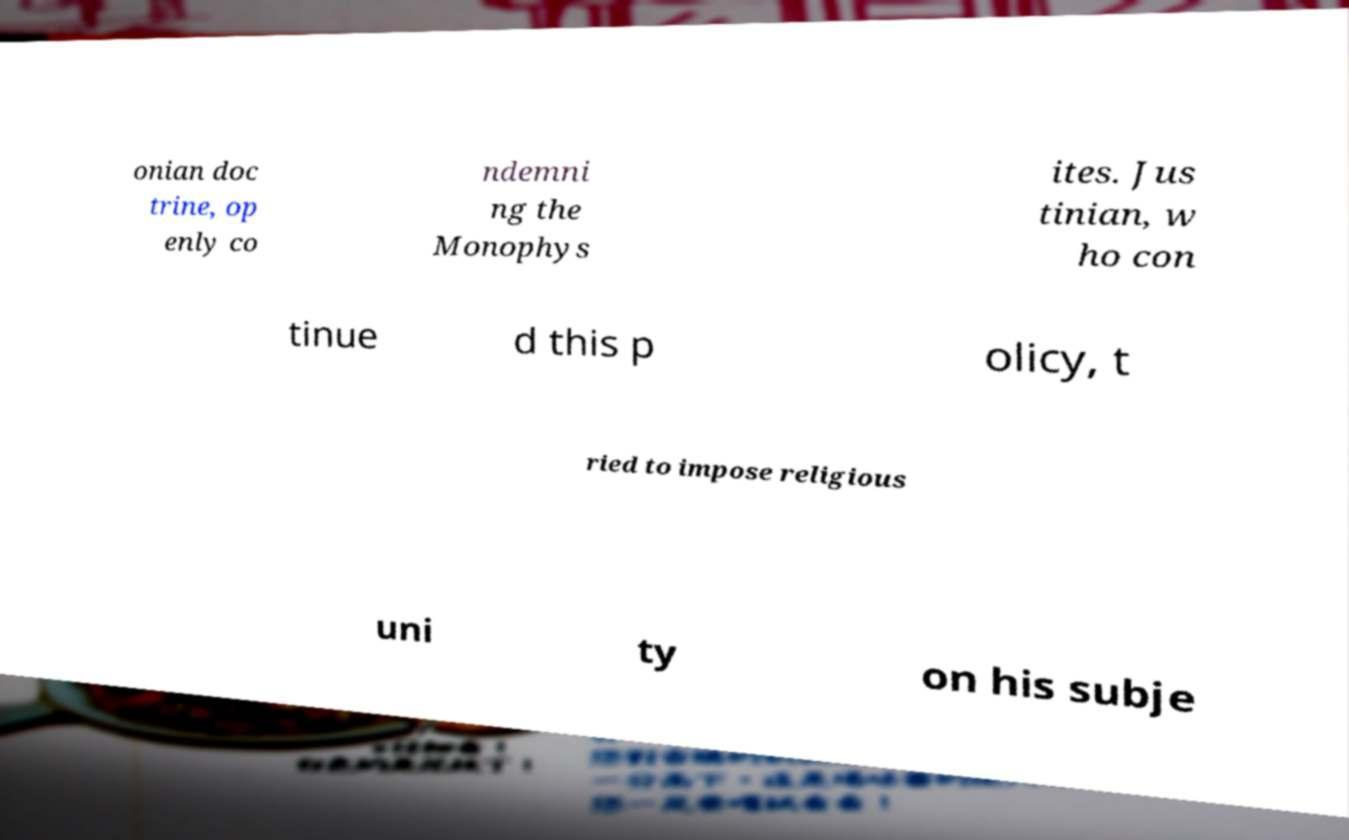Can you read and provide the text displayed in the image?This photo seems to have some interesting text. Can you extract and type it out for me? onian doc trine, op enly co ndemni ng the Monophys ites. Jus tinian, w ho con tinue d this p olicy, t ried to impose religious uni ty on his subje 